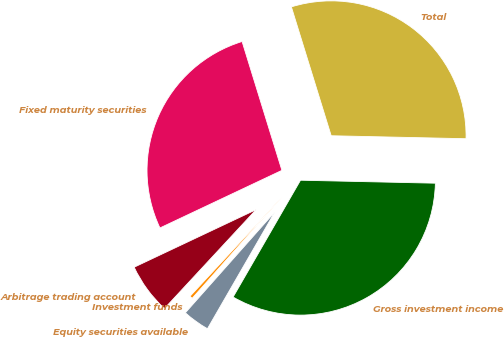<chart> <loc_0><loc_0><loc_500><loc_500><pie_chart><fcel>Fixed maturity securities<fcel>Arbitrage trading account<fcel>Investment funds<fcel>Equity securities available<fcel>Gross investment income<fcel>Total<nl><fcel>27.25%<fcel>6.08%<fcel>0.35%<fcel>3.22%<fcel>32.98%<fcel>30.12%<nl></chart> 